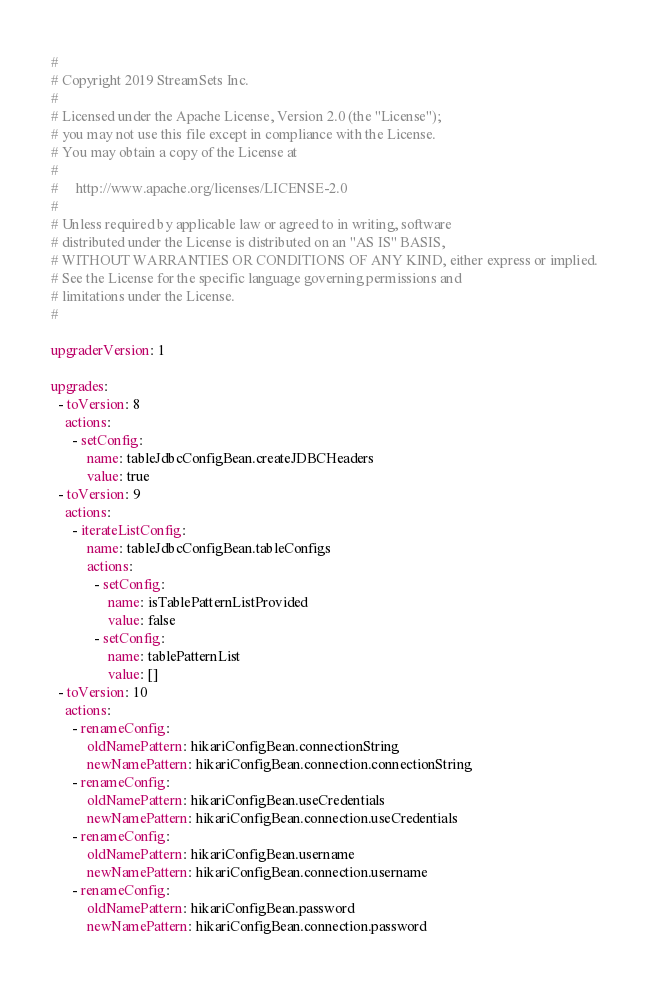<code> <loc_0><loc_0><loc_500><loc_500><_YAML_>#
# Copyright 2019 StreamSets Inc.
#
# Licensed under the Apache License, Version 2.0 (the "License");
# you may not use this file except in compliance with the License.
# You may obtain a copy of the License at
#
#     http://www.apache.org/licenses/LICENSE-2.0
#
# Unless required by applicable law or agreed to in writing, software
# distributed under the License is distributed on an "AS IS" BASIS,
# WITHOUT WARRANTIES OR CONDITIONS OF ANY KIND, either express or implied.
# See the License for the specific language governing permissions and
# limitations under the License.
#

upgraderVersion: 1

upgrades:
  - toVersion: 8
    actions:
      - setConfig:
          name: tableJdbcConfigBean.createJDBCHeaders
          value: true
  - toVersion: 9
    actions:
      - iterateListConfig:
          name: tableJdbcConfigBean.tableConfigs
          actions:
            - setConfig:
                name: isTablePatternListProvided
                value: false
            - setConfig:
                name: tablePatternList
                value: []
  - toVersion: 10
    actions:
      - renameConfig:
          oldNamePattern: hikariConfigBean.connectionString
          newNamePattern: hikariConfigBean.connection.connectionString
      - renameConfig:
          oldNamePattern: hikariConfigBean.useCredentials
          newNamePattern: hikariConfigBean.connection.useCredentials
      - renameConfig:
          oldNamePattern: hikariConfigBean.username
          newNamePattern: hikariConfigBean.connection.username
      - renameConfig:
          oldNamePattern: hikariConfigBean.password
          newNamePattern: hikariConfigBean.connection.password</code> 